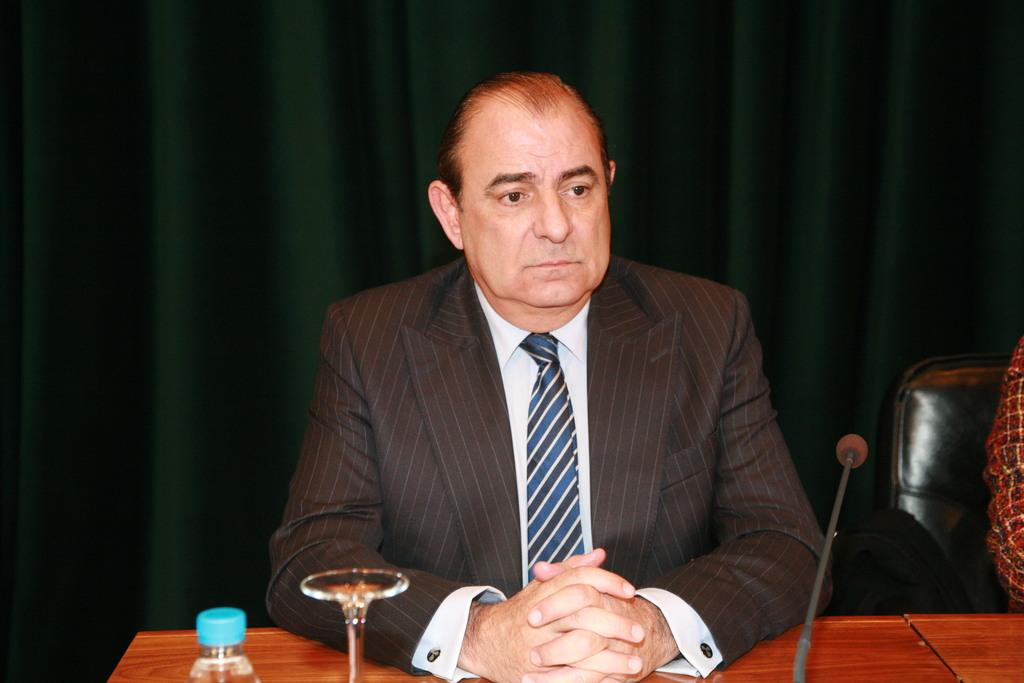What is the man in the image doing? The man is sitting on a chair in the image. What is located on the table in the image? There is a glass, a bottle, and a microphone (mike) on the table in the image. What can be seen in the background of the image? There is a curtain in the background of the image. How many sisters are present in the image? There are no sisters mentioned or visible in the image. What type of shoe can be seen on the table? There is no shoe present on the table in the image. 